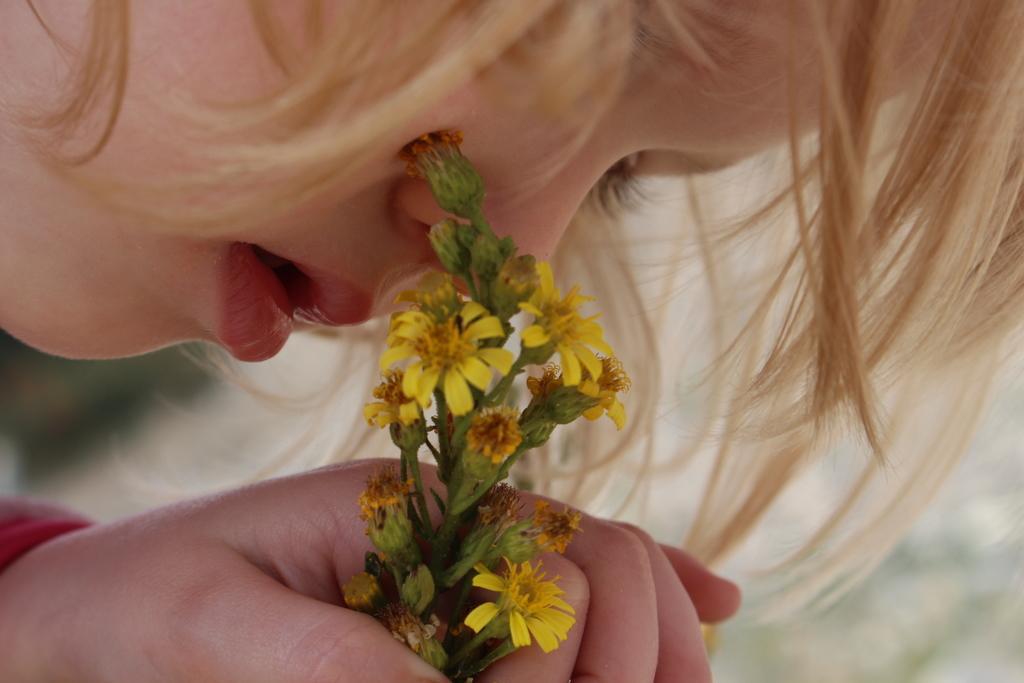Can you describe this image briefly? In this picture there is a girl, she is holding flowers. On the right we can see her hairs. She is wearing red dress. 